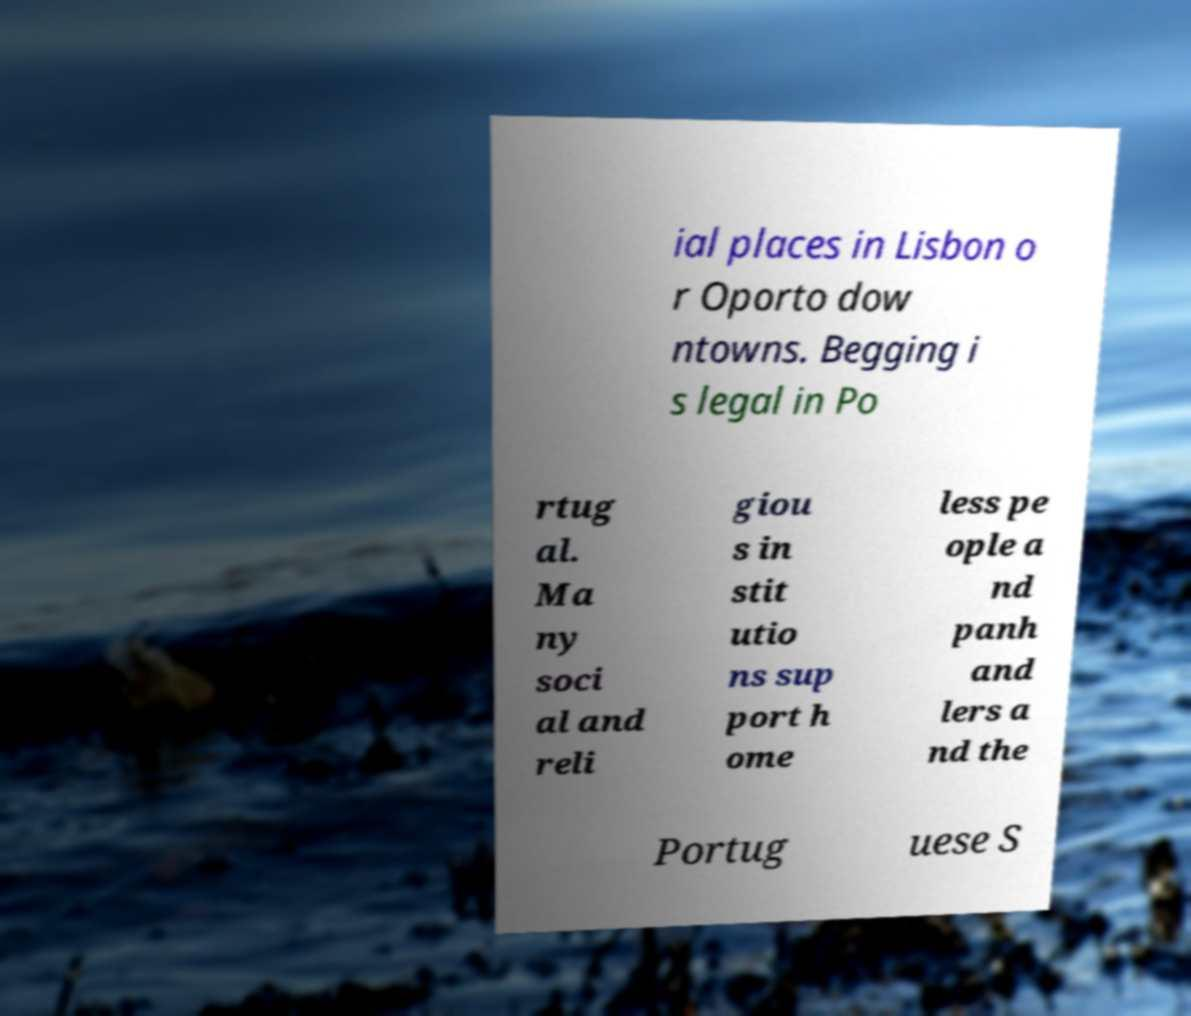Can you read and provide the text displayed in the image?This photo seems to have some interesting text. Can you extract and type it out for me? ial places in Lisbon o r Oporto dow ntowns. Begging i s legal in Po rtug al. Ma ny soci al and reli giou s in stit utio ns sup port h ome less pe ople a nd panh and lers a nd the Portug uese S 